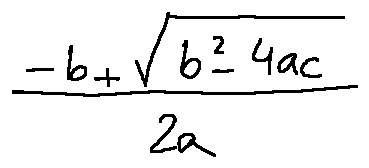Convert formula to latex. <formula><loc_0><loc_0><loc_500><loc_500>\frac { - b + \sqrt { b ^ { 2 } - 4 a c } } { 2 a }</formula> 